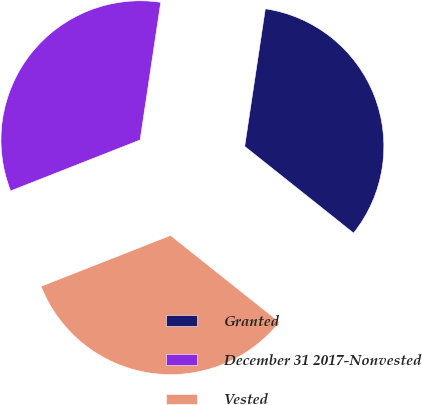<chart> <loc_0><loc_0><loc_500><loc_500><pie_chart><fcel>Granted<fcel>December 31 2017-Nonvested<fcel>Vested<nl><fcel>33.33%<fcel>33.33%<fcel>33.33%<nl></chart> 